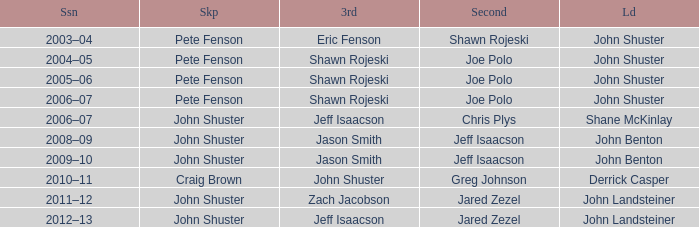Who was the lead with John Shuster as skip, Chris Plys in second, and Jeff Isaacson in third? Shane McKinlay. Give me the full table as a dictionary. {'header': ['Ssn', 'Skp', '3rd', 'Second', 'Ld'], 'rows': [['2003–04', 'Pete Fenson', 'Eric Fenson', 'Shawn Rojeski', 'John Shuster'], ['2004–05', 'Pete Fenson', 'Shawn Rojeski', 'Joe Polo', 'John Shuster'], ['2005–06', 'Pete Fenson', 'Shawn Rojeski', 'Joe Polo', 'John Shuster'], ['2006–07', 'Pete Fenson', 'Shawn Rojeski', 'Joe Polo', 'John Shuster'], ['2006–07', 'John Shuster', 'Jeff Isaacson', 'Chris Plys', 'Shane McKinlay'], ['2008–09', 'John Shuster', 'Jason Smith', 'Jeff Isaacson', 'John Benton'], ['2009–10', 'John Shuster', 'Jason Smith', 'Jeff Isaacson', 'John Benton'], ['2010–11', 'Craig Brown', 'John Shuster', 'Greg Johnson', 'Derrick Casper'], ['2011–12', 'John Shuster', 'Zach Jacobson', 'Jared Zezel', 'John Landsteiner'], ['2012–13', 'John Shuster', 'Jeff Isaacson', 'Jared Zezel', 'John Landsteiner']]} 